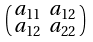<formula> <loc_0><loc_0><loc_500><loc_500>\begin{psmallmatrix} a _ { 1 1 } & a _ { 1 2 } \\ a _ { 1 2 } & a _ { 2 2 } \end{psmallmatrix}</formula> 